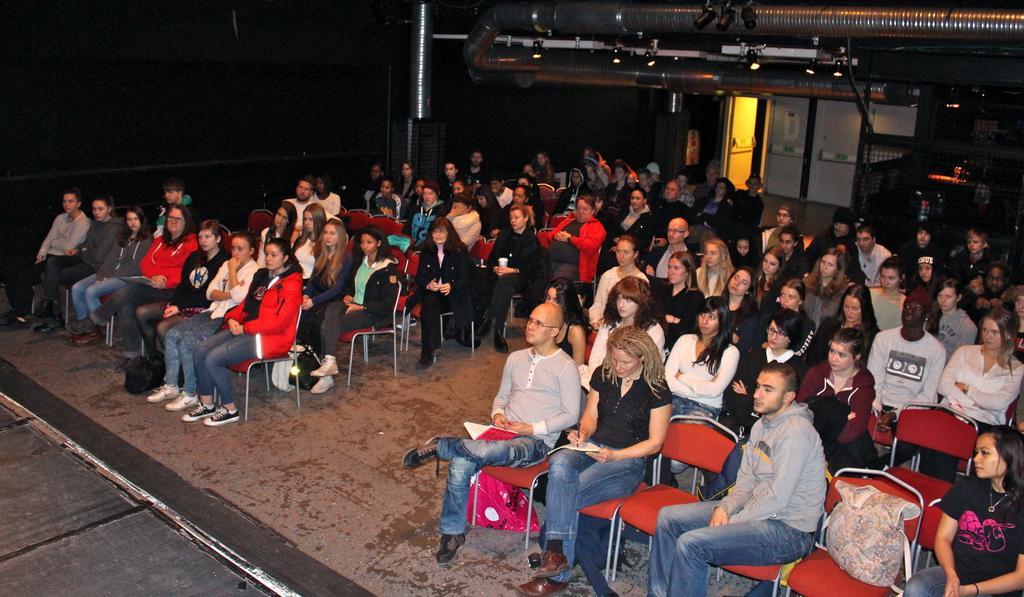Please provide a concise description of this image. In this image there are group of persons sitting, there are cars, there are persons holding an object, there are doors, there are pipes towards the top of the image, there is the wall towards the top of the image, there are objects on the ground, there is an object towards the left of the image, there are objects towards the right of the image, there is a bag on the chair. 